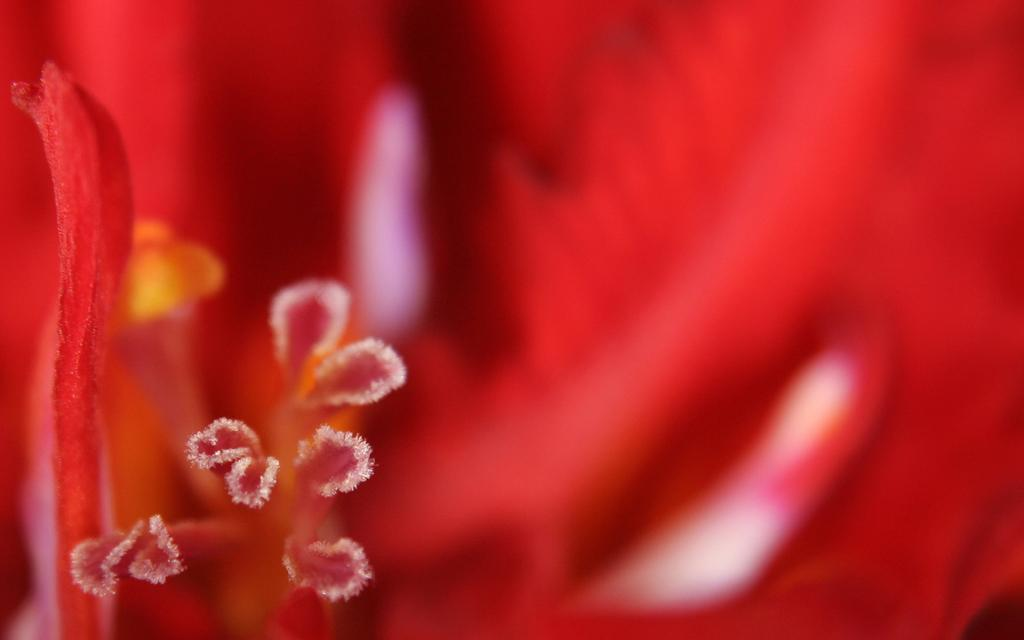What type of flower is present in the image? There is a red color flower in the image. Can you hear the flower making any sounds in the image? Flowers do not make sounds, so there are no sounds to hear in the image. Does the flower provide a home for any animals in the image? The image does not show any animals living in or around the flower. 